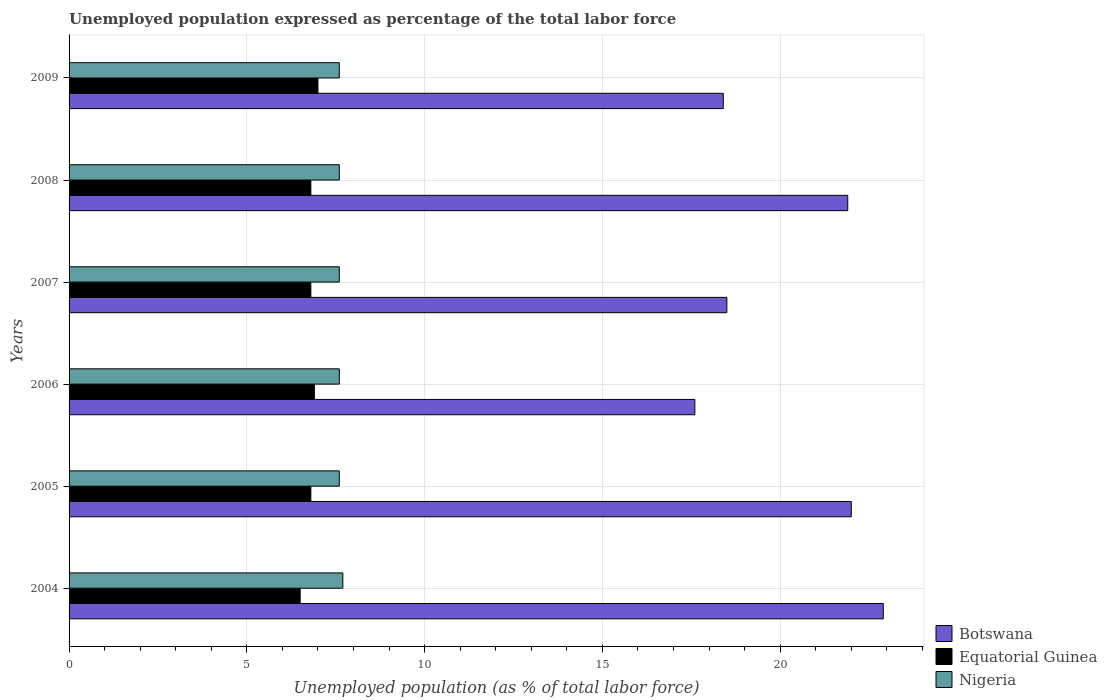How many different coloured bars are there?
Provide a succinct answer. 3. How many groups of bars are there?
Keep it short and to the point. 6. Are the number of bars on each tick of the Y-axis equal?
Keep it short and to the point. Yes. How many bars are there on the 2nd tick from the bottom?
Your response must be concise. 3. What is the label of the 6th group of bars from the top?
Offer a terse response. 2004. What is the unemployment in in Botswana in 2009?
Give a very brief answer. 18.4. Across all years, what is the maximum unemployment in in Botswana?
Provide a succinct answer. 22.9. Across all years, what is the minimum unemployment in in Nigeria?
Give a very brief answer. 7.6. In which year was the unemployment in in Nigeria minimum?
Ensure brevity in your answer.  2005. What is the total unemployment in in Nigeria in the graph?
Ensure brevity in your answer.  45.7. What is the difference between the unemployment in in Botswana in 2004 and that in 2008?
Provide a succinct answer. 1. What is the difference between the unemployment in in Nigeria in 2006 and the unemployment in in Equatorial Guinea in 2007?
Keep it short and to the point. 0.8. What is the average unemployment in in Nigeria per year?
Provide a short and direct response. 7.62. In the year 2009, what is the difference between the unemployment in in Botswana and unemployment in in Equatorial Guinea?
Your answer should be compact. 11.4. What is the ratio of the unemployment in in Equatorial Guinea in 2004 to that in 2005?
Keep it short and to the point. 0.96. Is the unemployment in in Nigeria in 2006 less than that in 2009?
Keep it short and to the point. No. Is the difference between the unemployment in in Botswana in 2006 and 2008 greater than the difference between the unemployment in in Equatorial Guinea in 2006 and 2008?
Your answer should be compact. No. What is the difference between the highest and the second highest unemployment in in Equatorial Guinea?
Ensure brevity in your answer.  0.1. What is the difference between the highest and the lowest unemployment in in Equatorial Guinea?
Offer a very short reply. 0.5. What does the 2nd bar from the top in 2006 represents?
Provide a short and direct response. Equatorial Guinea. What does the 3rd bar from the bottom in 2007 represents?
Make the answer very short. Nigeria. Is it the case that in every year, the sum of the unemployment in in Nigeria and unemployment in in Botswana is greater than the unemployment in in Equatorial Guinea?
Offer a very short reply. Yes. How many bars are there?
Offer a terse response. 18. What is the difference between two consecutive major ticks on the X-axis?
Ensure brevity in your answer.  5. Are the values on the major ticks of X-axis written in scientific E-notation?
Ensure brevity in your answer.  No. How many legend labels are there?
Provide a succinct answer. 3. What is the title of the graph?
Keep it short and to the point. Unemployed population expressed as percentage of the total labor force. What is the label or title of the X-axis?
Your answer should be compact. Unemployed population (as % of total labor force). What is the Unemployed population (as % of total labor force) of Botswana in 2004?
Give a very brief answer. 22.9. What is the Unemployed population (as % of total labor force) in Equatorial Guinea in 2004?
Give a very brief answer. 6.5. What is the Unemployed population (as % of total labor force) of Nigeria in 2004?
Offer a terse response. 7.7. What is the Unemployed population (as % of total labor force) in Equatorial Guinea in 2005?
Make the answer very short. 6.8. What is the Unemployed population (as % of total labor force) in Nigeria in 2005?
Keep it short and to the point. 7.6. What is the Unemployed population (as % of total labor force) in Botswana in 2006?
Keep it short and to the point. 17.6. What is the Unemployed population (as % of total labor force) of Equatorial Guinea in 2006?
Your response must be concise. 6.9. What is the Unemployed population (as % of total labor force) in Nigeria in 2006?
Your answer should be compact. 7.6. What is the Unemployed population (as % of total labor force) of Equatorial Guinea in 2007?
Your answer should be very brief. 6.8. What is the Unemployed population (as % of total labor force) of Nigeria in 2007?
Your answer should be very brief. 7.6. What is the Unemployed population (as % of total labor force) of Botswana in 2008?
Your response must be concise. 21.9. What is the Unemployed population (as % of total labor force) of Equatorial Guinea in 2008?
Your response must be concise. 6.8. What is the Unemployed population (as % of total labor force) of Nigeria in 2008?
Keep it short and to the point. 7.6. What is the Unemployed population (as % of total labor force) of Botswana in 2009?
Your answer should be very brief. 18.4. What is the Unemployed population (as % of total labor force) of Equatorial Guinea in 2009?
Provide a short and direct response. 7. What is the Unemployed population (as % of total labor force) in Nigeria in 2009?
Provide a succinct answer. 7.6. Across all years, what is the maximum Unemployed population (as % of total labor force) of Botswana?
Make the answer very short. 22.9. Across all years, what is the maximum Unemployed population (as % of total labor force) in Nigeria?
Your answer should be compact. 7.7. Across all years, what is the minimum Unemployed population (as % of total labor force) in Botswana?
Your answer should be very brief. 17.6. Across all years, what is the minimum Unemployed population (as % of total labor force) of Nigeria?
Ensure brevity in your answer.  7.6. What is the total Unemployed population (as % of total labor force) of Botswana in the graph?
Make the answer very short. 121.3. What is the total Unemployed population (as % of total labor force) of Equatorial Guinea in the graph?
Give a very brief answer. 40.8. What is the total Unemployed population (as % of total labor force) of Nigeria in the graph?
Your answer should be compact. 45.7. What is the difference between the Unemployed population (as % of total labor force) in Botswana in 2004 and that in 2005?
Provide a succinct answer. 0.9. What is the difference between the Unemployed population (as % of total labor force) in Nigeria in 2004 and that in 2005?
Your response must be concise. 0.1. What is the difference between the Unemployed population (as % of total labor force) in Botswana in 2004 and that in 2006?
Ensure brevity in your answer.  5.3. What is the difference between the Unemployed population (as % of total labor force) of Nigeria in 2004 and that in 2006?
Give a very brief answer. 0.1. What is the difference between the Unemployed population (as % of total labor force) of Nigeria in 2004 and that in 2007?
Your response must be concise. 0.1. What is the difference between the Unemployed population (as % of total labor force) of Botswana in 2004 and that in 2008?
Provide a succinct answer. 1. What is the difference between the Unemployed population (as % of total labor force) of Equatorial Guinea in 2004 and that in 2008?
Your answer should be compact. -0.3. What is the difference between the Unemployed population (as % of total labor force) in Nigeria in 2004 and that in 2008?
Provide a succinct answer. 0.1. What is the difference between the Unemployed population (as % of total labor force) in Botswana in 2004 and that in 2009?
Ensure brevity in your answer.  4.5. What is the difference between the Unemployed population (as % of total labor force) of Equatorial Guinea in 2004 and that in 2009?
Your answer should be compact. -0.5. What is the difference between the Unemployed population (as % of total labor force) in Botswana in 2005 and that in 2008?
Your answer should be very brief. 0.1. What is the difference between the Unemployed population (as % of total labor force) of Equatorial Guinea in 2005 and that in 2008?
Offer a terse response. 0. What is the difference between the Unemployed population (as % of total labor force) in Nigeria in 2005 and that in 2009?
Provide a short and direct response. 0. What is the difference between the Unemployed population (as % of total labor force) of Botswana in 2006 and that in 2007?
Your response must be concise. -0.9. What is the difference between the Unemployed population (as % of total labor force) of Equatorial Guinea in 2006 and that in 2007?
Keep it short and to the point. 0.1. What is the difference between the Unemployed population (as % of total labor force) in Botswana in 2006 and that in 2008?
Provide a short and direct response. -4.3. What is the difference between the Unemployed population (as % of total labor force) of Equatorial Guinea in 2006 and that in 2008?
Your answer should be very brief. 0.1. What is the difference between the Unemployed population (as % of total labor force) of Nigeria in 2006 and that in 2008?
Your response must be concise. 0. What is the difference between the Unemployed population (as % of total labor force) in Nigeria in 2006 and that in 2009?
Offer a terse response. 0. What is the difference between the Unemployed population (as % of total labor force) of Nigeria in 2007 and that in 2008?
Provide a succinct answer. 0. What is the difference between the Unemployed population (as % of total labor force) of Botswana in 2008 and that in 2009?
Provide a short and direct response. 3.5. What is the difference between the Unemployed population (as % of total labor force) of Equatorial Guinea in 2008 and that in 2009?
Offer a terse response. -0.2. What is the difference between the Unemployed population (as % of total labor force) in Botswana in 2004 and the Unemployed population (as % of total labor force) in Equatorial Guinea in 2005?
Ensure brevity in your answer.  16.1. What is the difference between the Unemployed population (as % of total labor force) of Botswana in 2004 and the Unemployed population (as % of total labor force) of Equatorial Guinea in 2006?
Give a very brief answer. 16. What is the difference between the Unemployed population (as % of total labor force) of Botswana in 2004 and the Unemployed population (as % of total labor force) of Nigeria in 2006?
Offer a very short reply. 15.3. What is the difference between the Unemployed population (as % of total labor force) in Equatorial Guinea in 2004 and the Unemployed population (as % of total labor force) in Nigeria in 2006?
Your response must be concise. -1.1. What is the difference between the Unemployed population (as % of total labor force) in Botswana in 2004 and the Unemployed population (as % of total labor force) in Nigeria in 2007?
Make the answer very short. 15.3. What is the difference between the Unemployed population (as % of total labor force) of Botswana in 2004 and the Unemployed population (as % of total labor force) of Equatorial Guinea in 2008?
Your response must be concise. 16.1. What is the difference between the Unemployed population (as % of total labor force) of Equatorial Guinea in 2004 and the Unemployed population (as % of total labor force) of Nigeria in 2008?
Offer a terse response. -1.1. What is the difference between the Unemployed population (as % of total labor force) in Botswana in 2004 and the Unemployed population (as % of total labor force) in Equatorial Guinea in 2009?
Offer a very short reply. 15.9. What is the difference between the Unemployed population (as % of total labor force) in Botswana in 2004 and the Unemployed population (as % of total labor force) in Nigeria in 2009?
Provide a succinct answer. 15.3. What is the difference between the Unemployed population (as % of total labor force) of Botswana in 2005 and the Unemployed population (as % of total labor force) of Nigeria in 2006?
Your response must be concise. 14.4. What is the difference between the Unemployed population (as % of total labor force) of Botswana in 2005 and the Unemployed population (as % of total labor force) of Equatorial Guinea in 2007?
Provide a succinct answer. 15.2. What is the difference between the Unemployed population (as % of total labor force) of Botswana in 2005 and the Unemployed population (as % of total labor force) of Nigeria in 2009?
Your answer should be very brief. 14.4. What is the difference between the Unemployed population (as % of total labor force) in Equatorial Guinea in 2005 and the Unemployed population (as % of total labor force) in Nigeria in 2009?
Provide a short and direct response. -0.8. What is the difference between the Unemployed population (as % of total labor force) in Botswana in 2006 and the Unemployed population (as % of total labor force) in Nigeria in 2007?
Offer a very short reply. 10. What is the difference between the Unemployed population (as % of total labor force) in Equatorial Guinea in 2006 and the Unemployed population (as % of total labor force) in Nigeria in 2007?
Keep it short and to the point. -0.7. What is the difference between the Unemployed population (as % of total labor force) in Botswana in 2006 and the Unemployed population (as % of total labor force) in Nigeria in 2008?
Your response must be concise. 10. What is the difference between the Unemployed population (as % of total labor force) in Equatorial Guinea in 2006 and the Unemployed population (as % of total labor force) in Nigeria in 2008?
Your answer should be very brief. -0.7. What is the difference between the Unemployed population (as % of total labor force) in Botswana in 2006 and the Unemployed population (as % of total labor force) in Equatorial Guinea in 2009?
Make the answer very short. 10.6. What is the difference between the Unemployed population (as % of total labor force) in Botswana in 2007 and the Unemployed population (as % of total labor force) in Equatorial Guinea in 2008?
Keep it short and to the point. 11.7. What is the difference between the Unemployed population (as % of total labor force) of Botswana in 2007 and the Unemployed population (as % of total labor force) of Nigeria in 2008?
Ensure brevity in your answer.  10.9. What is the difference between the Unemployed population (as % of total labor force) of Equatorial Guinea in 2007 and the Unemployed population (as % of total labor force) of Nigeria in 2008?
Make the answer very short. -0.8. What is the difference between the Unemployed population (as % of total labor force) of Botswana in 2007 and the Unemployed population (as % of total labor force) of Nigeria in 2009?
Make the answer very short. 10.9. What is the difference between the Unemployed population (as % of total labor force) of Botswana in 2008 and the Unemployed population (as % of total labor force) of Nigeria in 2009?
Your answer should be compact. 14.3. What is the difference between the Unemployed population (as % of total labor force) of Equatorial Guinea in 2008 and the Unemployed population (as % of total labor force) of Nigeria in 2009?
Make the answer very short. -0.8. What is the average Unemployed population (as % of total labor force) in Botswana per year?
Your answer should be very brief. 20.22. What is the average Unemployed population (as % of total labor force) in Equatorial Guinea per year?
Make the answer very short. 6.8. What is the average Unemployed population (as % of total labor force) in Nigeria per year?
Your answer should be compact. 7.62. In the year 2005, what is the difference between the Unemployed population (as % of total labor force) of Botswana and Unemployed population (as % of total labor force) of Equatorial Guinea?
Offer a very short reply. 15.2. In the year 2005, what is the difference between the Unemployed population (as % of total labor force) of Equatorial Guinea and Unemployed population (as % of total labor force) of Nigeria?
Offer a very short reply. -0.8. In the year 2006, what is the difference between the Unemployed population (as % of total labor force) in Botswana and Unemployed population (as % of total labor force) in Equatorial Guinea?
Provide a succinct answer. 10.7. In the year 2006, what is the difference between the Unemployed population (as % of total labor force) in Botswana and Unemployed population (as % of total labor force) in Nigeria?
Provide a short and direct response. 10. In the year 2006, what is the difference between the Unemployed population (as % of total labor force) in Equatorial Guinea and Unemployed population (as % of total labor force) in Nigeria?
Provide a short and direct response. -0.7. In the year 2007, what is the difference between the Unemployed population (as % of total labor force) of Botswana and Unemployed population (as % of total labor force) of Equatorial Guinea?
Provide a succinct answer. 11.7. In the year 2007, what is the difference between the Unemployed population (as % of total labor force) in Equatorial Guinea and Unemployed population (as % of total labor force) in Nigeria?
Offer a terse response. -0.8. In the year 2008, what is the difference between the Unemployed population (as % of total labor force) of Botswana and Unemployed population (as % of total labor force) of Nigeria?
Your answer should be compact. 14.3. In the year 2009, what is the difference between the Unemployed population (as % of total labor force) of Botswana and Unemployed population (as % of total labor force) of Nigeria?
Keep it short and to the point. 10.8. In the year 2009, what is the difference between the Unemployed population (as % of total labor force) of Equatorial Guinea and Unemployed population (as % of total labor force) of Nigeria?
Your answer should be very brief. -0.6. What is the ratio of the Unemployed population (as % of total labor force) in Botswana in 2004 to that in 2005?
Offer a terse response. 1.04. What is the ratio of the Unemployed population (as % of total labor force) in Equatorial Guinea in 2004 to that in 2005?
Ensure brevity in your answer.  0.96. What is the ratio of the Unemployed population (as % of total labor force) of Nigeria in 2004 to that in 2005?
Offer a very short reply. 1.01. What is the ratio of the Unemployed population (as % of total labor force) of Botswana in 2004 to that in 2006?
Offer a very short reply. 1.3. What is the ratio of the Unemployed population (as % of total labor force) of Equatorial Guinea in 2004 to that in 2006?
Offer a very short reply. 0.94. What is the ratio of the Unemployed population (as % of total labor force) in Nigeria in 2004 to that in 2006?
Provide a succinct answer. 1.01. What is the ratio of the Unemployed population (as % of total labor force) of Botswana in 2004 to that in 2007?
Ensure brevity in your answer.  1.24. What is the ratio of the Unemployed population (as % of total labor force) of Equatorial Guinea in 2004 to that in 2007?
Offer a very short reply. 0.96. What is the ratio of the Unemployed population (as % of total labor force) of Nigeria in 2004 to that in 2007?
Your answer should be very brief. 1.01. What is the ratio of the Unemployed population (as % of total labor force) in Botswana in 2004 to that in 2008?
Offer a very short reply. 1.05. What is the ratio of the Unemployed population (as % of total labor force) in Equatorial Guinea in 2004 to that in 2008?
Your answer should be very brief. 0.96. What is the ratio of the Unemployed population (as % of total labor force) in Nigeria in 2004 to that in 2008?
Provide a succinct answer. 1.01. What is the ratio of the Unemployed population (as % of total labor force) in Botswana in 2004 to that in 2009?
Offer a very short reply. 1.24. What is the ratio of the Unemployed population (as % of total labor force) in Equatorial Guinea in 2004 to that in 2009?
Make the answer very short. 0.93. What is the ratio of the Unemployed population (as % of total labor force) in Nigeria in 2004 to that in 2009?
Make the answer very short. 1.01. What is the ratio of the Unemployed population (as % of total labor force) in Equatorial Guinea in 2005 to that in 2006?
Provide a short and direct response. 0.99. What is the ratio of the Unemployed population (as % of total labor force) of Nigeria in 2005 to that in 2006?
Ensure brevity in your answer.  1. What is the ratio of the Unemployed population (as % of total labor force) in Botswana in 2005 to that in 2007?
Offer a terse response. 1.19. What is the ratio of the Unemployed population (as % of total labor force) of Botswana in 2005 to that in 2009?
Offer a terse response. 1.2. What is the ratio of the Unemployed population (as % of total labor force) of Equatorial Guinea in 2005 to that in 2009?
Your answer should be compact. 0.97. What is the ratio of the Unemployed population (as % of total labor force) of Botswana in 2006 to that in 2007?
Ensure brevity in your answer.  0.95. What is the ratio of the Unemployed population (as % of total labor force) of Equatorial Guinea in 2006 to that in 2007?
Ensure brevity in your answer.  1.01. What is the ratio of the Unemployed population (as % of total labor force) of Nigeria in 2006 to that in 2007?
Ensure brevity in your answer.  1. What is the ratio of the Unemployed population (as % of total labor force) of Botswana in 2006 to that in 2008?
Ensure brevity in your answer.  0.8. What is the ratio of the Unemployed population (as % of total labor force) in Equatorial Guinea in 2006 to that in 2008?
Offer a terse response. 1.01. What is the ratio of the Unemployed population (as % of total labor force) of Nigeria in 2006 to that in 2008?
Your answer should be very brief. 1. What is the ratio of the Unemployed population (as % of total labor force) of Botswana in 2006 to that in 2009?
Provide a succinct answer. 0.96. What is the ratio of the Unemployed population (as % of total labor force) of Equatorial Guinea in 2006 to that in 2009?
Keep it short and to the point. 0.99. What is the ratio of the Unemployed population (as % of total labor force) in Nigeria in 2006 to that in 2009?
Offer a terse response. 1. What is the ratio of the Unemployed population (as % of total labor force) in Botswana in 2007 to that in 2008?
Keep it short and to the point. 0.84. What is the ratio of the Unemployed population (as % of total labor force) in Botswana in 2007 to that in 2009?
Offer a terse response. 1.01. What is the ratio of the Unemployed population (as % of total labor force) in Equatorial Guinea in 2007 to that in 2009?
Keep it short and to the point. 0.97. What is the ratio of the Unemployed population (as % of total labor force) of Nigeria in 2007 to that in 2009?
Your answer should be very brief. 1. What is the ratio of the Unemployed population (as % of total labor force) in Botswana in 2008 to that in 2009?
Your response must be concise. 1.19. What is the ratio of the Unemployed population (as % of total labor force) of Equatorial Guinea in 2008 to that in 2009?
Your response must be concise. 0.97. What is the ratio of the Unemployed population (as % of total labor force) of Nigeria in 2008 to that in 2009?
Your answer should be compact. 1. What is the difference between the highest and the second highest Unemployed population (as % of total labor force) of Botswana?
Provide a succinct answer. 0.9. What is the difference between the highest and the lowest Unemployed population (as % of total labor force) in Botswana?
Keep it short and to the point. 5.3. 